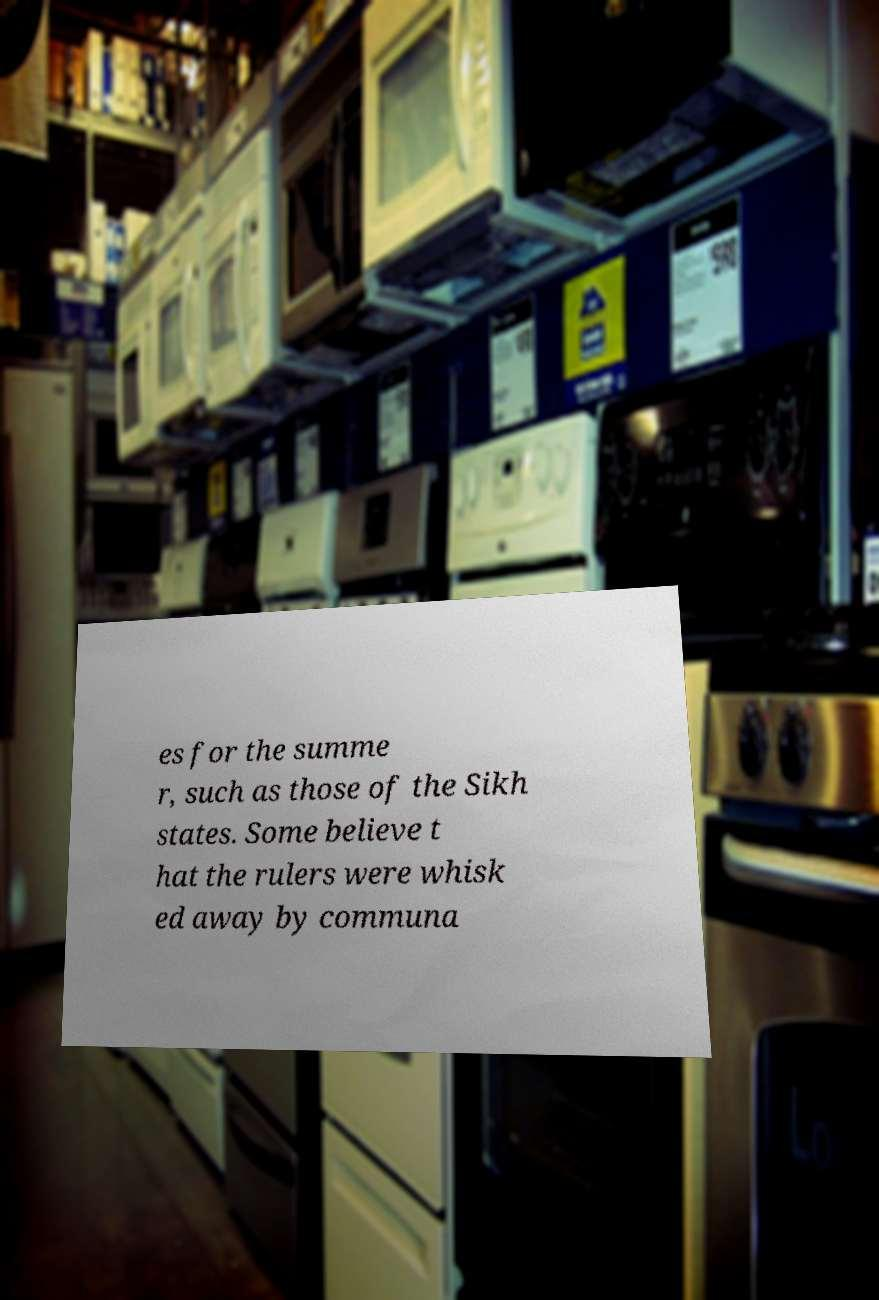Can you read and provide the text displayed in the image?This photo seems to have some interesting text. Can you extract and type it out for me? es for the summe r, such as those of the Sikh states. Some believe t hat the rulers were whisk ed away by communa 